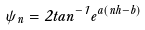Convert formula to latex. <formula><loc_0><loc_0><loc_500><loc_500>\psi _ { n } = 2 t a n ^ { - 1 } e ^ { a ( n h - b ) }</formula> 